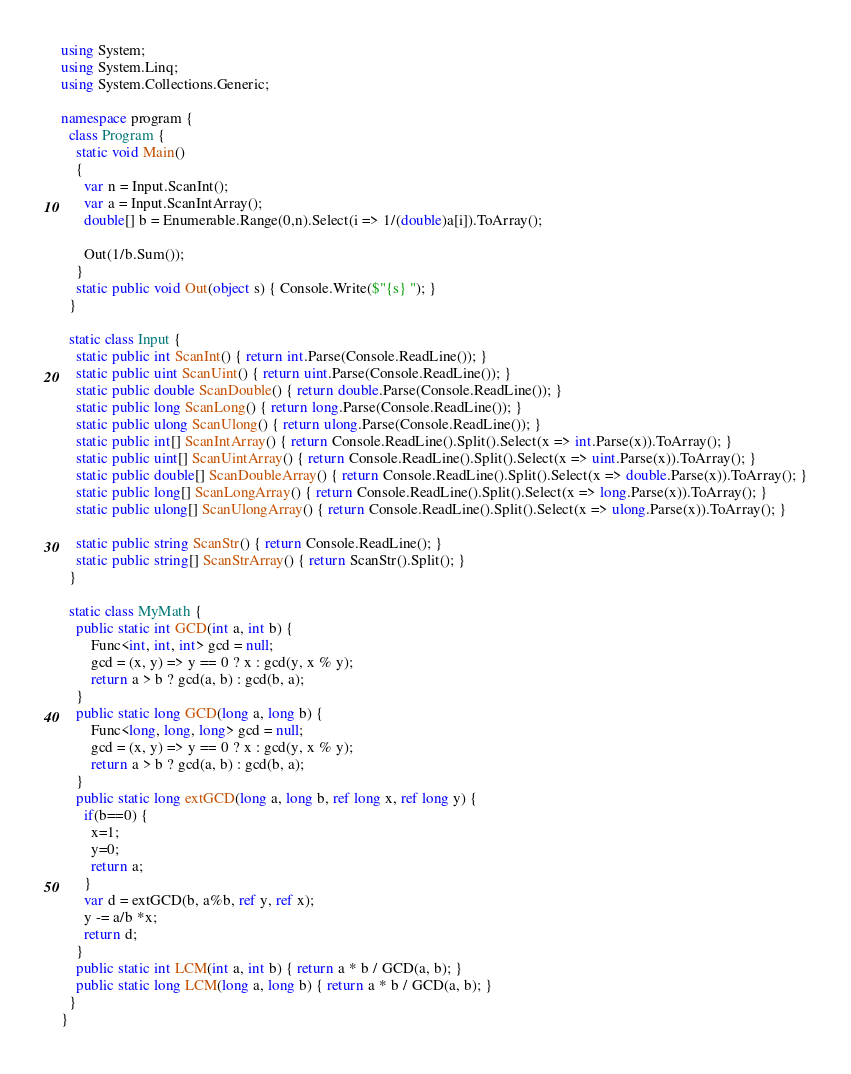<code> <loc_0><loc_0><loc_500><loc_500><_C#_>using System;
using System.Linq;
using System.Collections.Generic;

namespace program {
  class Program {
    static void Main()
    {
      var n = Input.ScanInt();
      var a = Input.ScanIntArray();
      double[] b = Enumerable.Range(0,n).Select(i => 1/(double)a[i]).ToArray();
      
      Out(1/b.Sum());
    }
    static public void Out(object s) { Console.Write($"{s} "); }
  }
  
  static class Input {
    static public int ScanInt() { return int.Parse(Console.ReadLine()); }
    static public uint ScanUint() { return uint.Parse(Console.ReadLine()); }
    static public double ScanDouble() { return double.Parse(Console.ReadLine()); }
    static public long ScanLong() { return long.Parse(Console.ReadLine()); }
    static public ulong ScanUlong() { return ulong.Parse(Console.ReadLine()); }
    static public int[] ScanIntArray() { return Console.ReadLine().Split().Select(x => int.Parse(x)).ToArray(); }
    static public uint[] ScanUintArray() { return Console.ReadLine().Split().Select(x => uint.Parse(x)).ToArray(); }
    static public double[] ScanDoubleArray() { return Console.ReadLine().Split().Select(x => double.Parse(x)).ToArray(); }
    static public long[] ScanLongArray() { return Console.ReadLine().Split().Select(x => long.Parse(x)).ToArray(); }
    static public ulong[] ScanUlongArray() { return Console.ReadLine().Split().Select(x => ulong.Parse(x)).ToArray(); }

    static public string ScanStr() { return Console.ReadLine(); }
    static public string[] ScanStrArray() { return ScanStr().Split(); }
  }
  
  static class MyMath {
    public static int GCD(int a, int b) {
        Func<int, int, int> gcd = null;
        gcd = (x, y) => y == 0 ? x : gcd(y, x % y);
        return a > b ? gcd(a, b) : gcd(b, a);
    }
    public static long GCD(long a, long b) {
        Func<long, long, long> gcd = null;
        gcd = (x, y) => y == 0 ? x : gcd(y, x % y);
        return a > b ? gcd(a, b) : gcd(b, a);
    }
    public static long extGCD(long a, long b, ref long x, ref long y) {
      if(b==0) {
        x=1; 
        y=0;
        return a;
      }
      var d = extGCD(b, a%b, ref y, ref x);
      y -= a/b *x;
      return d;
    }
    public static int LCM(int a, int b) { return a * b / GCD(a, b); }
    public static long LCM(long a, long b) { return a * b / GCD(a, b); }
  }
}
</code> 